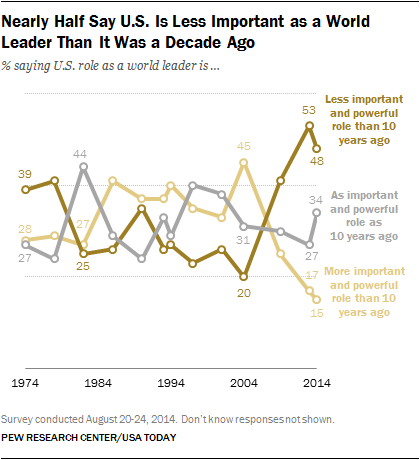Highlight a few significant elements in this photo. Grey segment represents an important and powerful role in the recruitment industry as it did 10 years ago. The highest value in a less important and less powerful role than 10 years ago is more than the highest value in a more important and more powerful role than 10 years ago, according to the data. 